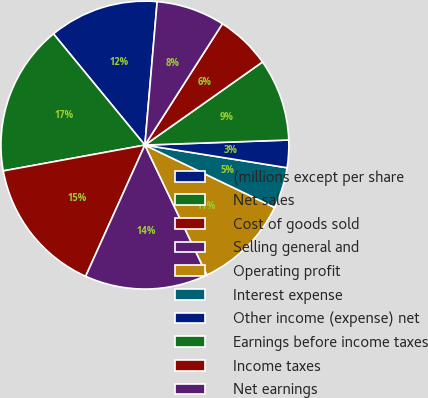Convert chart. <chart><loc_0><loc_0><loc_500><loc_500><pie_chart><fcel>(millions except per share<fcel>Net sales<fcel>Cost of goods sold<fcel>Selling general and<fcel>Operating profit<fcel>Interest expense<fcel>Other income (expense) net<fcel>Earnings before income taxes<fcel>Income taxes<fcel>Net earnings<nl><fcel>12.31%<fcel>16.92%<fcel>15.38%<fcel>13.84%<fcel>10.77%<fcel>4.62%<fcel>3.08%<fcel>9.23%<fcel>6.16%<fcel>7.69%<nl></chart> 